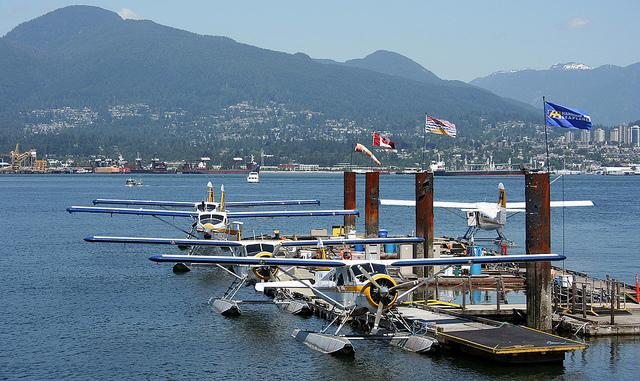What are the planes near the dock called? Please explain your reasoning. seaplane. The planes are the kind that can land on the sea and are called seaplanes. 